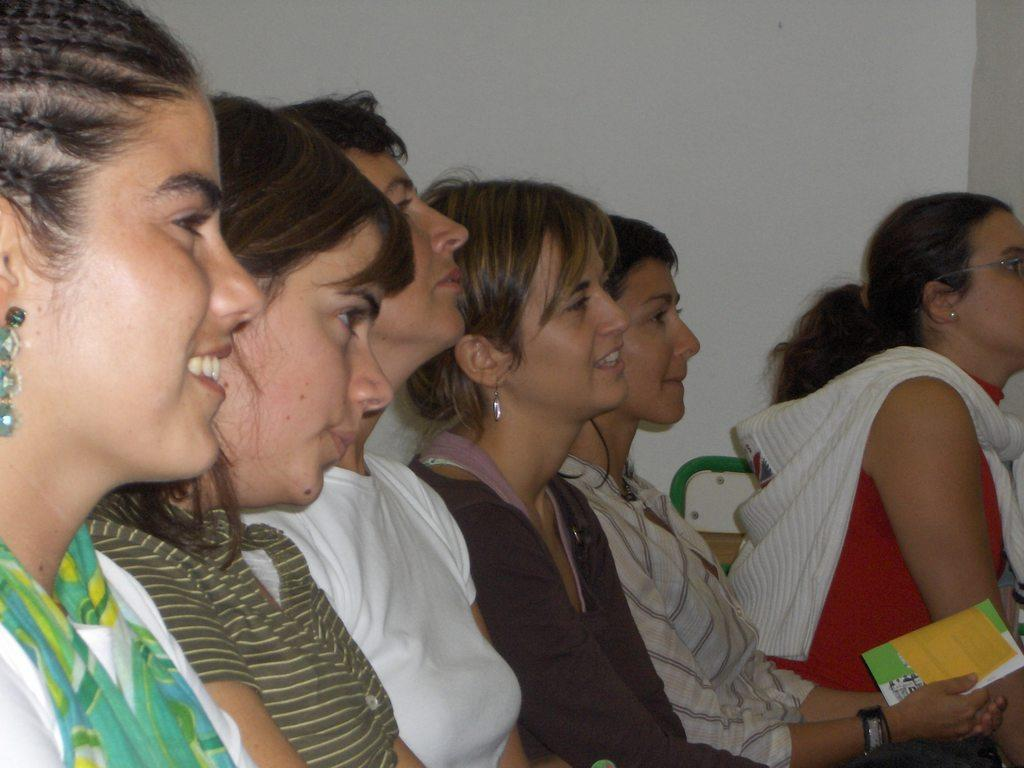Who is present in the image? There are women in the image. What are the women doing in the image? The women are sitting in chairs. Can you describe the expressions of the women? Some of the women are smiling. What can be seen in the background of the image? There is a wall in the background of the image. What type of shoes are the women wearing in the image? The provided facts do not mention any shoes, so we cannot determine what type of shoes the women are wearing. 